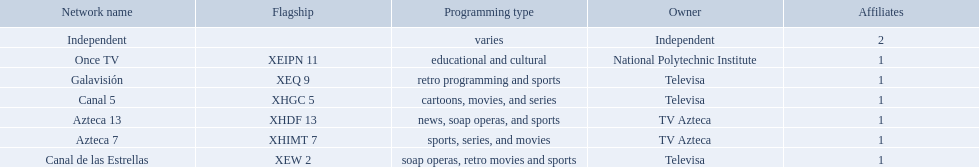What television stations are in morelos? Canal de las Estrellas, Canal 5, Azteca 7, Galavisión, Once TV, Azteca 13, Independent. Of those which network is owned by national polytechnic institute? Once TV. Which owner only owns one network? National Polytechnic Institute, Independent. Of those, what is the network name? Once TV, Independent. Of those, which programming type is educational and cultural? Once TV. 